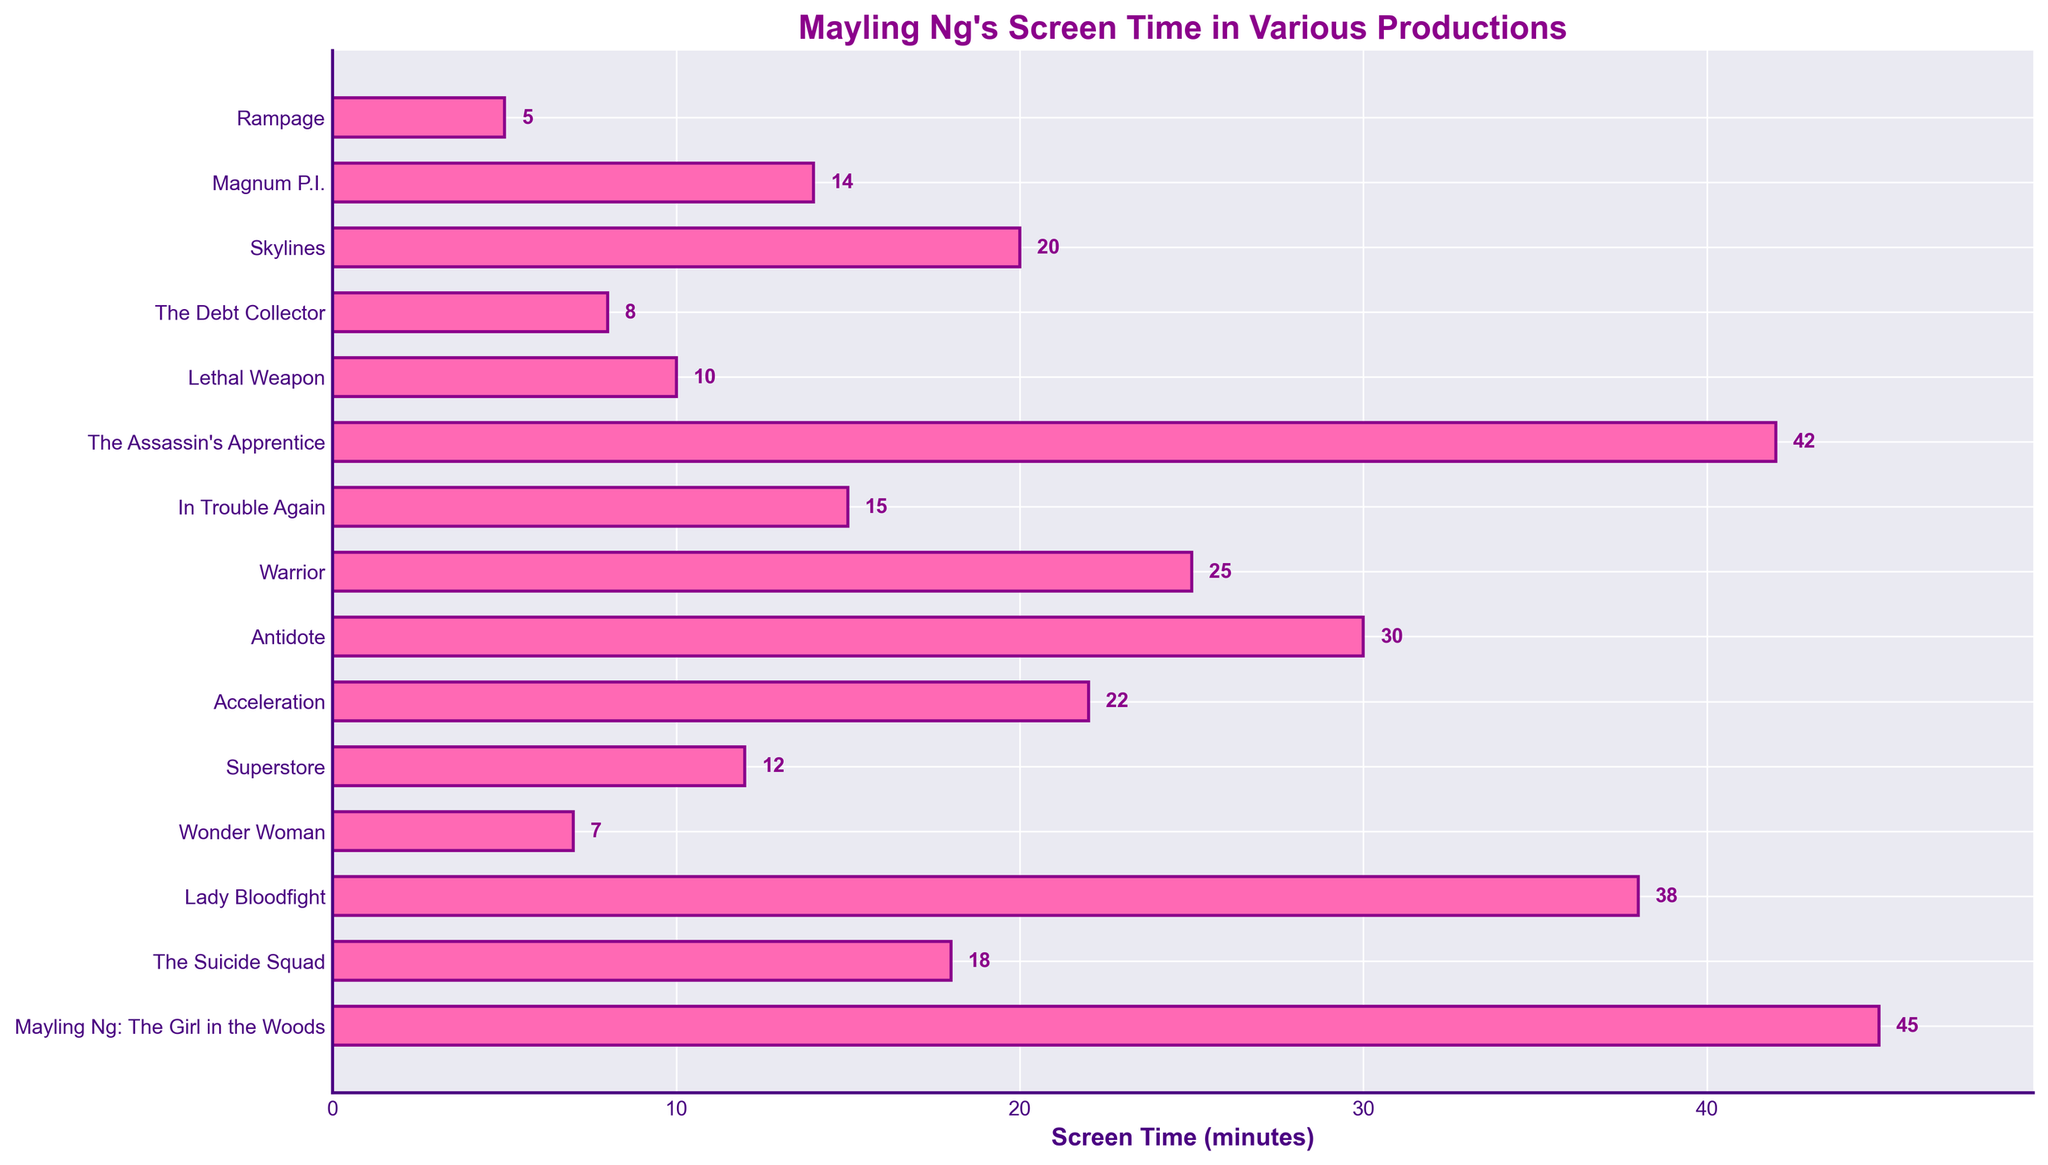Which production has the longest screen time for Mayling Ng? The bar associated with 'Mayling Ng: The Girl in the Woods' is the longest, indicating the highest screen time of 45 minutes.
Answer: Mayling Ng: The Girl in the Woods What is the total screen time for Mayling Ng in 'The Suicide Squad' and 'Wonder Woman'? Summing up the screen times for 'The Suicide Squad' (18 minutes) and 'Wonder Woman' (7 minutes) gives 18 + 7 = 25 minutes.
Answer: 25 minutes Which production has the shortest screen time for Mayling Ng? The shortest bar corresponds to 'Rampage,' indicating the shortest screen time of 5 minutes.
Answer: Rampage How much more screen time does 'The Assassin's Apprentice' have compared to 'Superstore'? The screen time for 'The Assassin's Apprentice' is 42 minutes, and for 'Superstore' it is 12 minutes. Subtracting these gives 42 - 12 = 30 minutes.
Answer: 30 minutes Rank the top three productions based on Mayling Ng's screen time. The top three productions based on screen time are 'Mayling Ng: The Girl in the Woods' (45 minutes), 'The Assassin's Apprentice' (42 minutes), and 'Lady Bloodfight' (38 minutes).
Answer: 1. Mayling Ng: The Girl in the Woods 2. The Assassin's Apprentice 3. Lady Bloodfight What is the average screen time across all productions listed? Summing all screen times: 45 + 18 + 38 + 7 + 12 + 22 + 30 + 25 + 15 + 42 + 10 + 8 + 20 + 14 + 5 = 311 minutes. Dividing by the number of productions (15) gives the average: 311 / 15 ≈ 20.7 minutes.
Answer: 20.7 minutes Which production has a screen time equal to 'Magnum P.I.' plus 'Warrior'? The screen time for 'Magnum P.I.' is 14 minutes, and for 'Warrior' it is 25 minutes. Adding these gives 14 + 25 = 39 minutes. No production exactly matches this screen time.
Answer: None Is Mayling Ng’s screen time in ‘Skylines’ less than or more than in ‘Acceleration’? The screen time in 'Skylines' is 20 minutes and in 'Acceleration' it is 22 minutes. Since 20 is less than 22, her screen time in 'Skylines' is less.
Answer: Less What is the combined screen time for all TV shows listed? Summing the screen times for TV shows ('Mayling Ng: The Girl in the Woods': 45 minutes, 'Superstore': 12 minutes, 'Warrior': 25 minutes, 'Magnum P.I.': 14 minutes, 'Lethal Weapon': 10 minutes) gives 45 + 12 + 25 + 14 + 10 = 106 minutes.
Answer: 106 minutes How much more screen time does 'Lady Bloodfight' have compared to 'The Debt Collector'? The screen time for 'Lady Bloodfight' is 38 minutes, and for 'The Debt Collector' it is 8 minutes. Subtracting these gives 38 - 8 = 30 minutes.
Answer: 30 minutes 